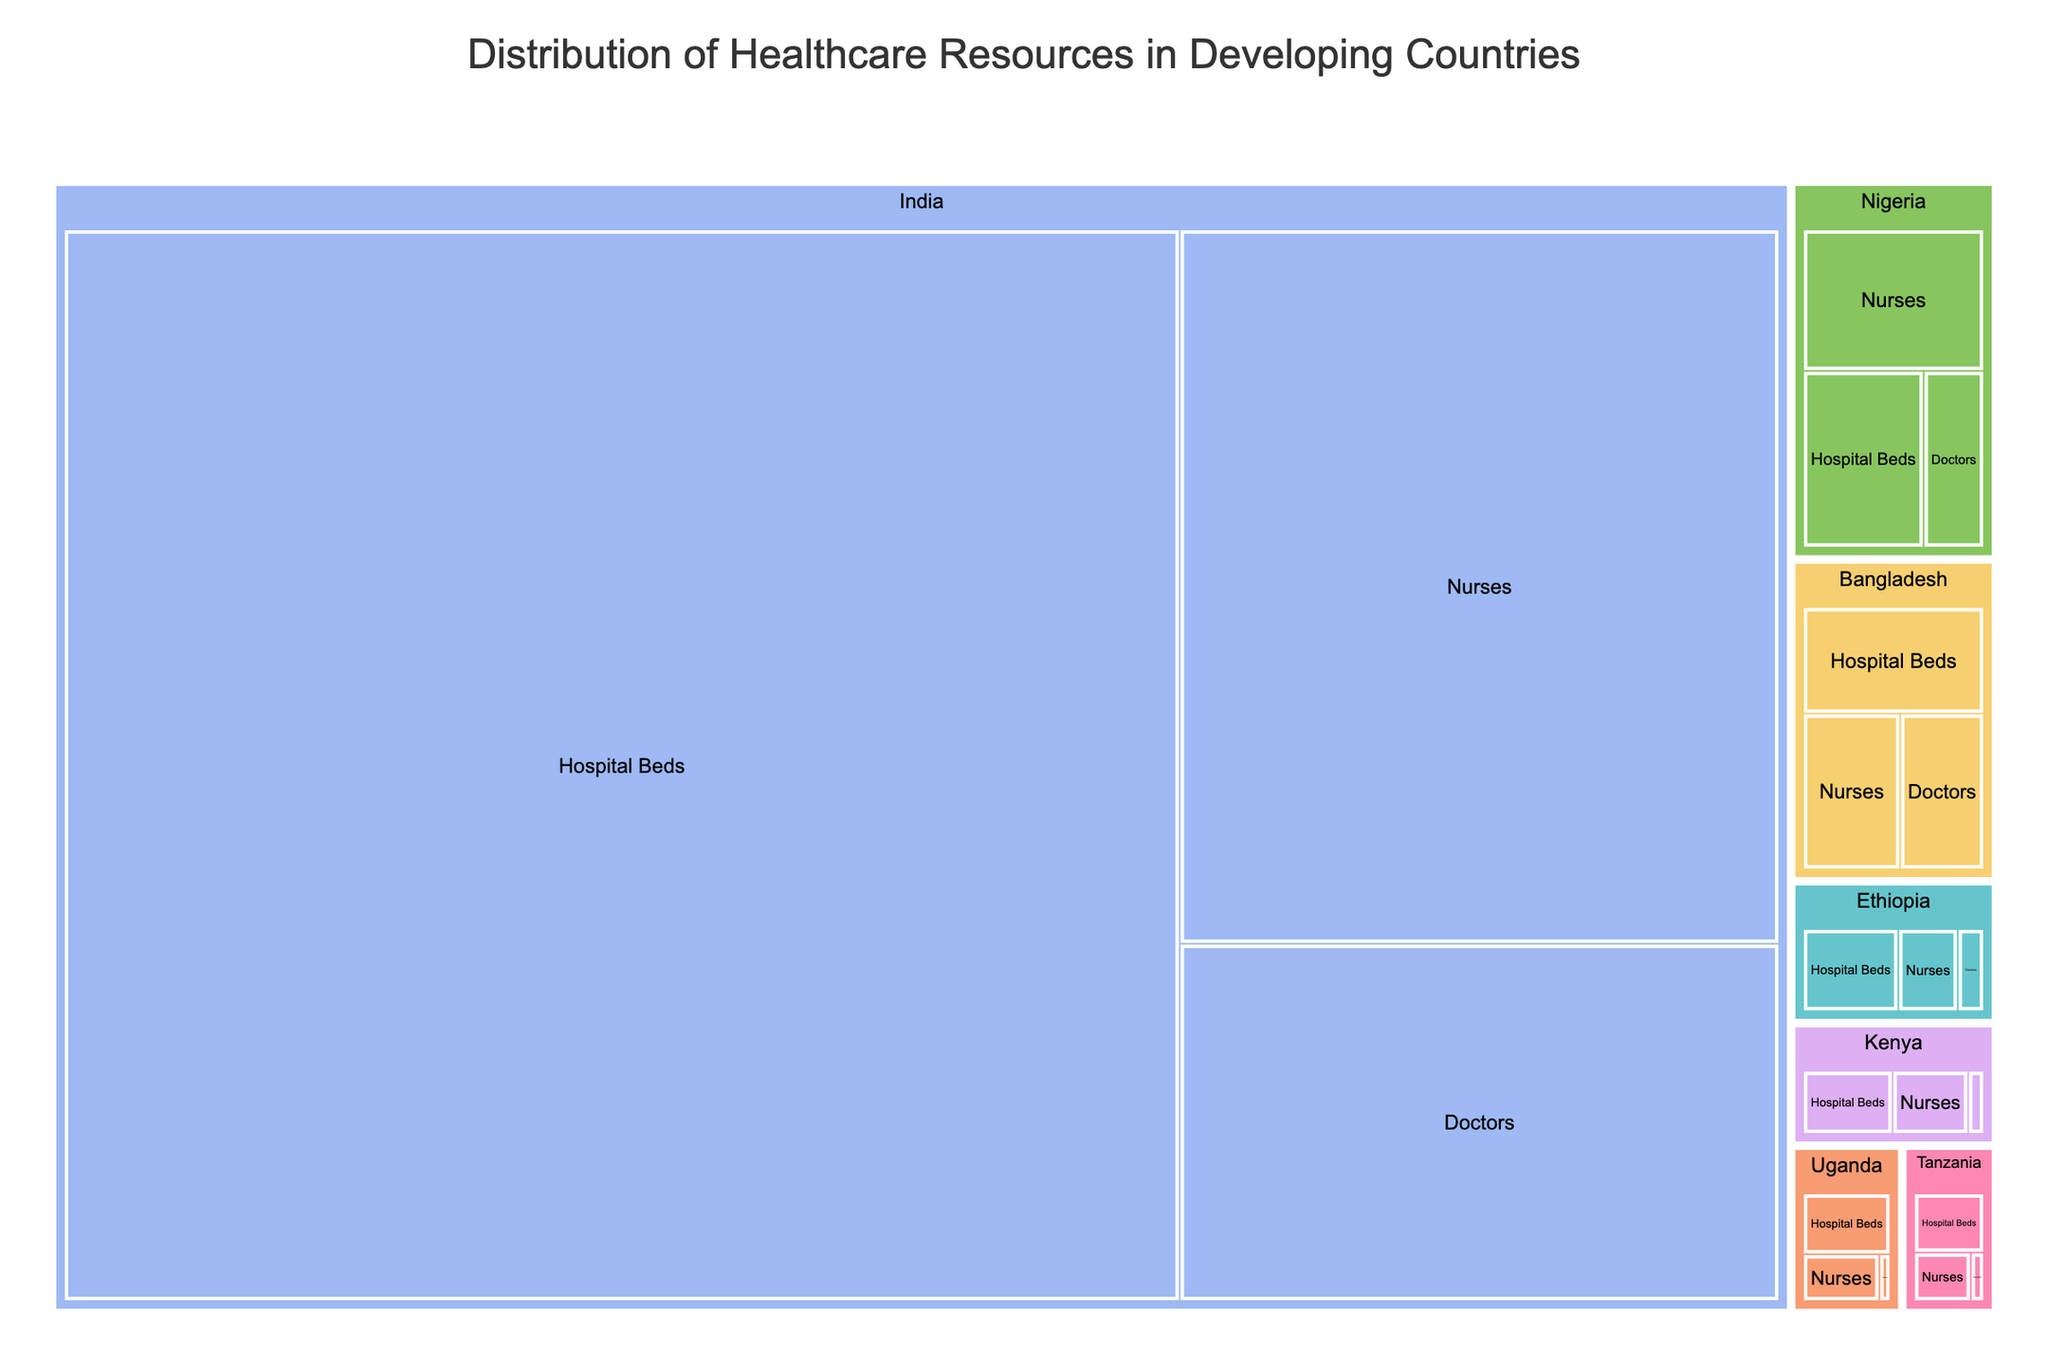What is the title of the treemap? The title is displayed at the top of the treemap and provides the main context of the visualization. By reading the title, you can understand the overall subject of the figure.
Answer: Distribution of Healthcare Resources in Developing Countries Which country has the largest single resource allocation, and what is it? To find the country with the largest allocation, look at the size of the rectangles in the treemap. The largest rectangle represents the highest resource allocation.
Answer: India with 6,700,000 hospital beds How many countries are represented in the treemap? Count the number of unique primary categories (countries) shown in the treemap. Each primary category represents a different country.
Answer: Six How does the number of doctors in India compare to Nigeria? Find the sections for doctors in both India and Nigeria and compare their sizes.
Answer: India has more doctors than Nigeria What is the total value of nurses in Bangladesh and Ethiopia combined? To find the total value, locate the value of nurses in both Bangladesh and Ethiopia and add them together. 110,000 (Bangladesh) + 50,000 (Ethiopia) = 160,000.
Answer: 160,000 Which resource type has the highest total allocation across all countries? Identify the resource type (hospital beds, doctors, nurses) in each country, sum their values, and compare. Hospital beds have the highest total allocation.
Answer: Hospital Beds What is the difference in the number of hospital beds between Ethiopia and Kenya? Subtract the value of hospital beds in Kenya from the value in Ethiopia to find the difference. 80,000 (Ethiopia) - 65,000 (Kenya) = 15,000.
Answer: 15,000 Which country has the smallest allocation of doctors, and what is the value? Find the smallest rectangle categorized under doctors and note the country and value.
Answer: Uganda with 5,300 doctors What percentage of India's healthcare resource allocation is for nurses? To calculate the percentage, divide the value of nurses in India by the total healthcare resources in India, and multiply by 100. Total resources in India = 6,700,000 (beds) + 1,200,000 (doctors) + 2,400,000 (nurses) = 10,300,000. Percentage for nurses = (2,400,000 / 10,300,000) * 100 ~ 23.3%.
Answer: ~23.3% How do the hospital beds in Tanzania compare to Uganda? Locate the values of hospital beds for both Tanzania and Uganda and compare their respective quantities.
Answer: Tanzania has fewer hospital beds than Uganda 